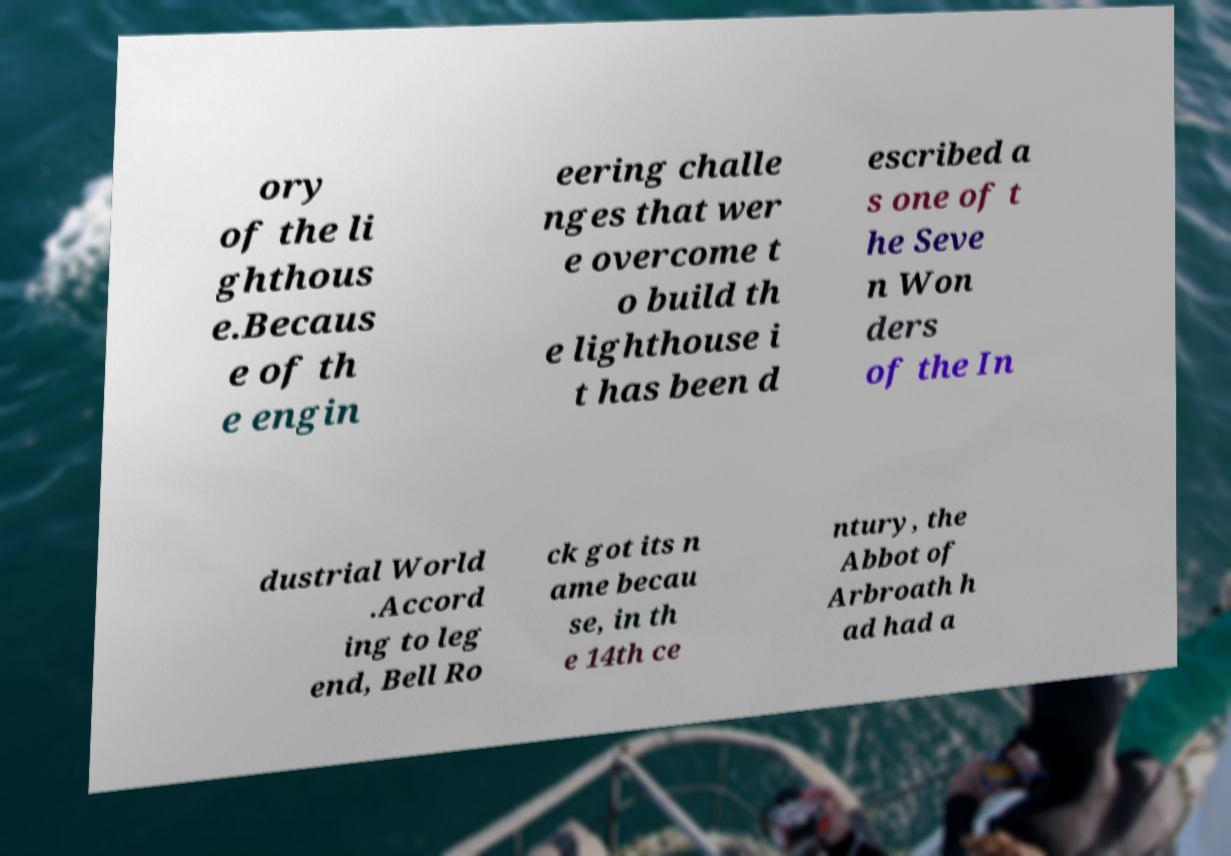Can you read and provide the text displayed in the image?This photo seems to have some interesting text. Can you extract and type it out for me? ory of the li ghthous e.Becaus e of th e engin eering challe nges that wer e overcome t o build th e lighthouse i t has been d escribed a s one of t he Seve n Won ders of the In dustrial World .Accord ing to leg end, Bell Ro ck got its n ame becau se, in th e 14th ce ntury, the Abbot of Arbroath h ad had a 